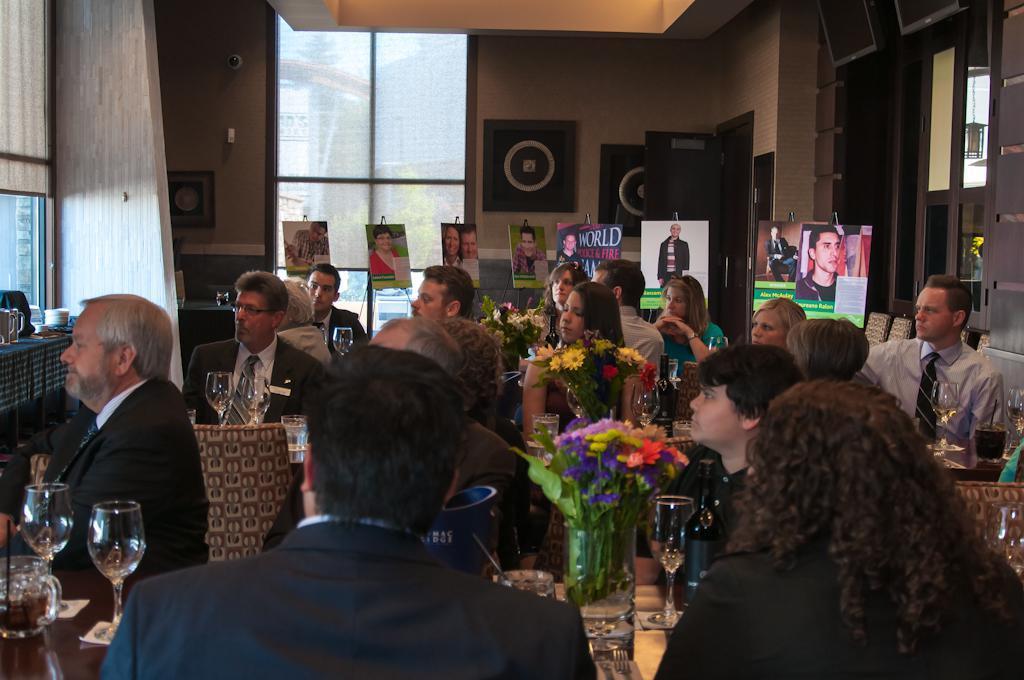Describe this image in one or two sentences. In this image we can see people sitting on chairs near table. We can see glasses, flower vases and some things on the table. In the background we can see boards, glass windows and doors. 